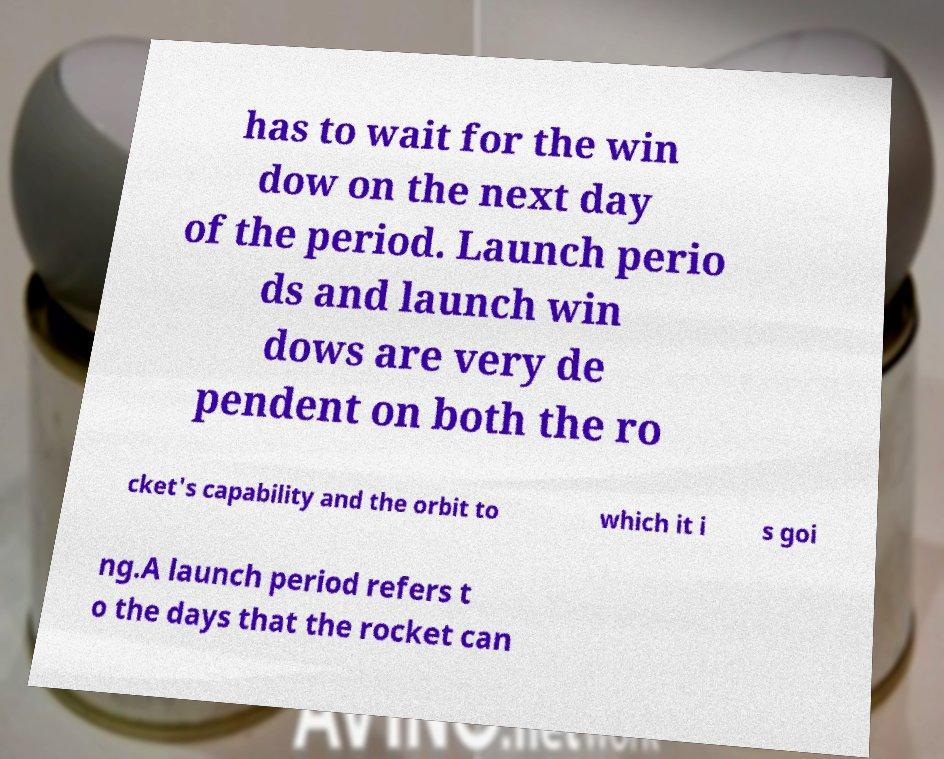There's text embedded in this image that I need extracted. Can you transcribe it verbatim? has to wait for the win dow on the next day of the period. Launch perio ds and launch win dows are very de pendent on both the ro cket's capability and the orbit to which it i s goi ng.A launch period refers t o the days that the rocket can 